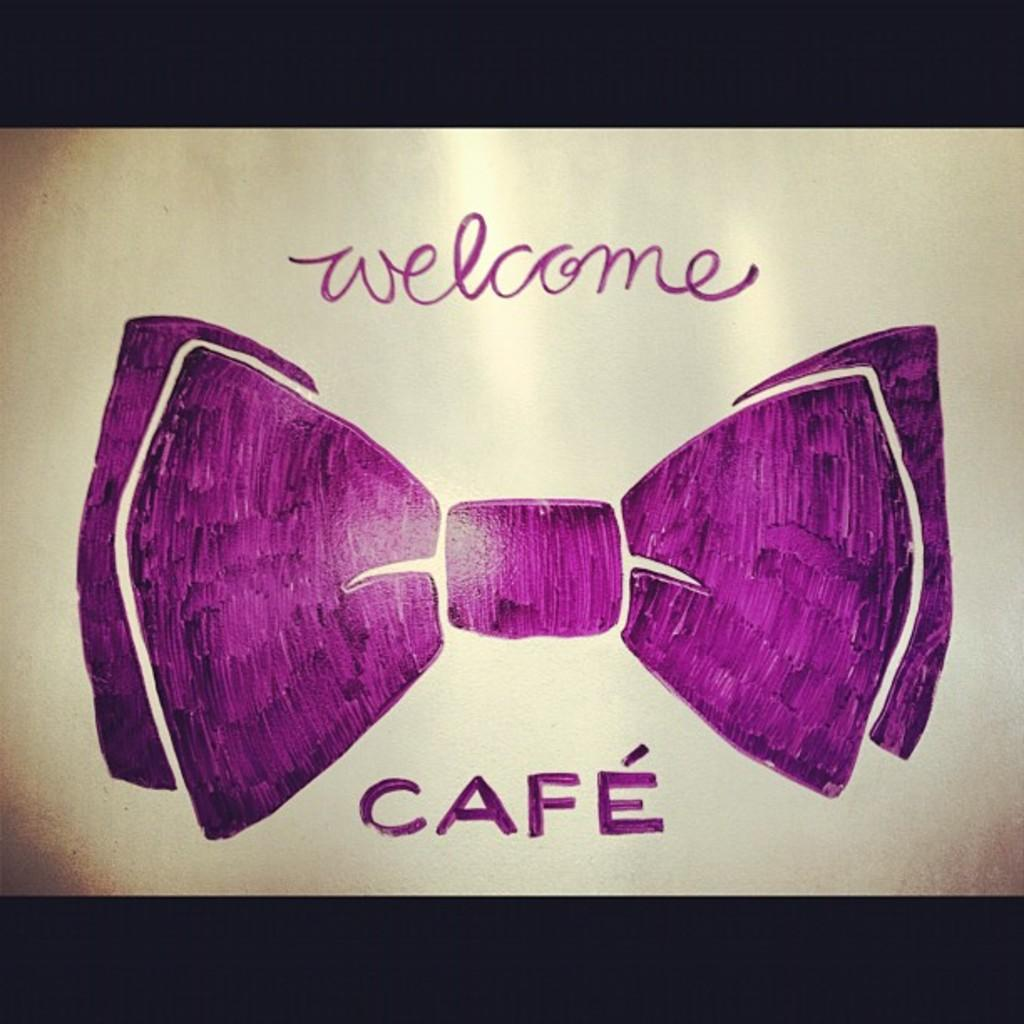What is depicted in the drawing in the image? There is a drawing of a bow tie in the image. What else can be found in the image besides the drawing? There is written text in the image. How many bears are shown wearing the bow tie in the image? There are no bears present in the image, and therefore no bears wearing the bow tie can be observed. 